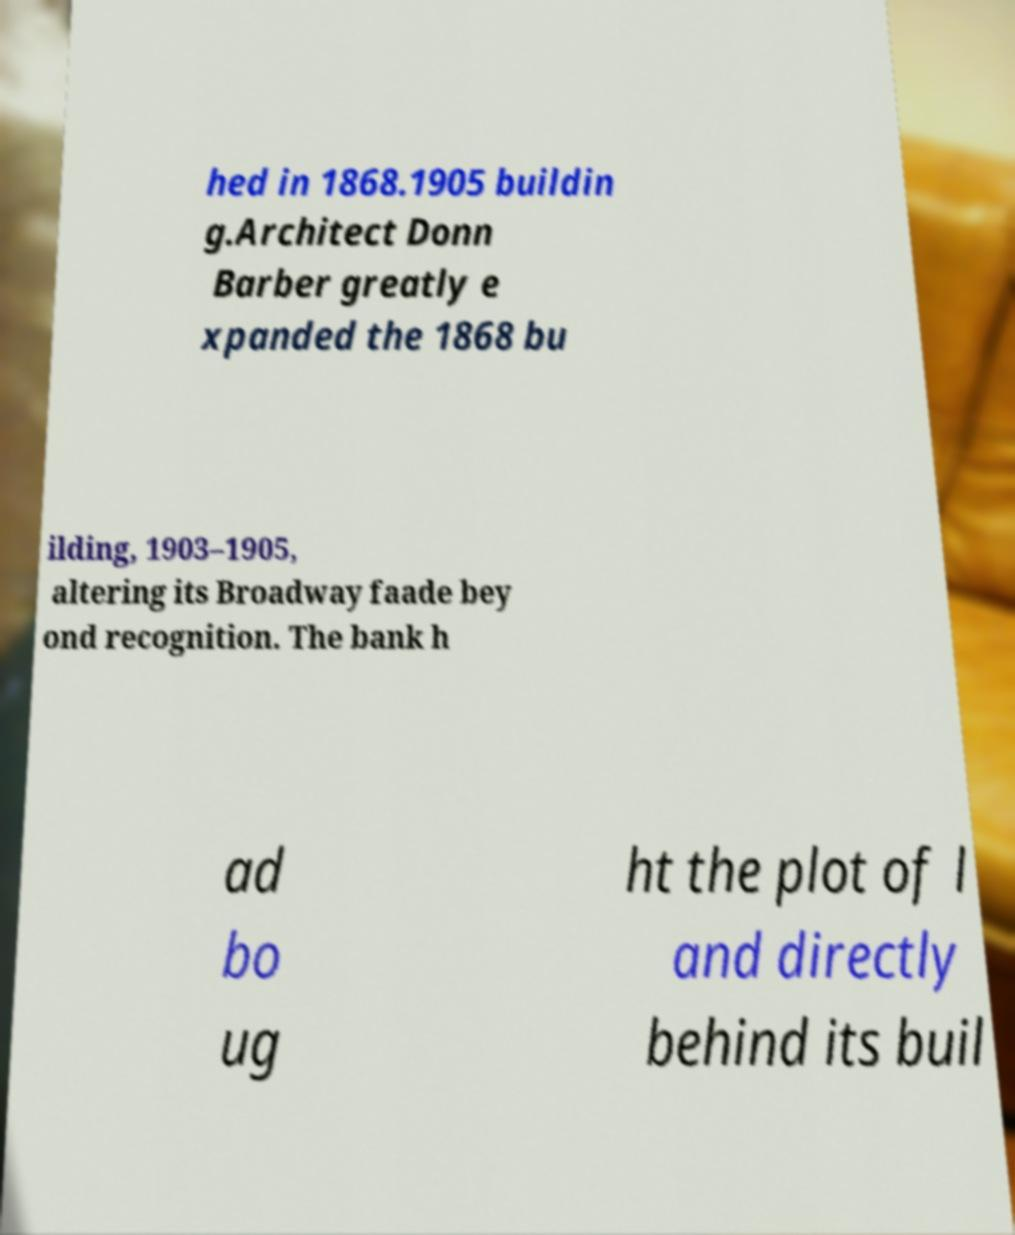For documentation purposes, I need the text within this image transcribed. Could you provide that? hed in 1868.1905 buildin g.Architect Donn Barber greatly e xpanded the 1868 bu ilding, 1903–1905, altering its Broadway faade bey ond recognition. The bank h ad bo ug ht the plot of l and directly behind its buil 